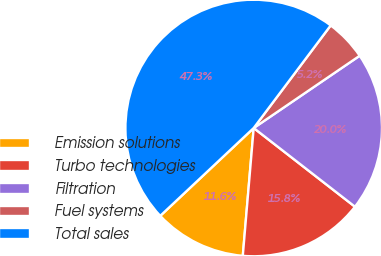<chart> <loc_0><loc_0><loc_500><loc_500><pie_chart><fcel>Emission solutions<fcel>Turbo technologies<fcel>Filtration<fcel>Fuel systems<fcel>Total sales<nl><fcel>11.64%<fcel>15.84%<fcel>20.04%<fcel>5.23%<fcel>47.26%<nl></chart> 